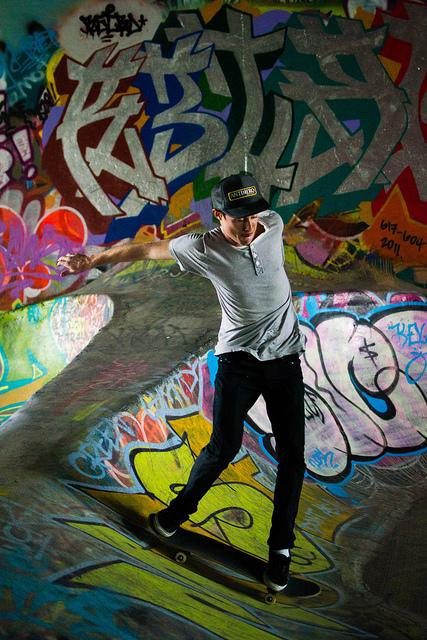Is this guy roller skating?
Write a very short answer. No. What color are this guy's pants?
Give a very brief answer. Black. Is there graffiti on the wall?
Quick response, please. Yes. 